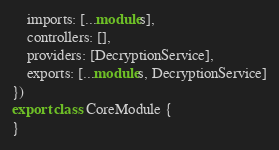<code> <loc_0><loc_0><loc_500><loc_500><_TypeScript_>	imports: [...modules],
	controllers: [],
	providers: [DecryptionService],
	exports: [...modules, DecryptionService]
})
export class CoreModule {
}
</code> 